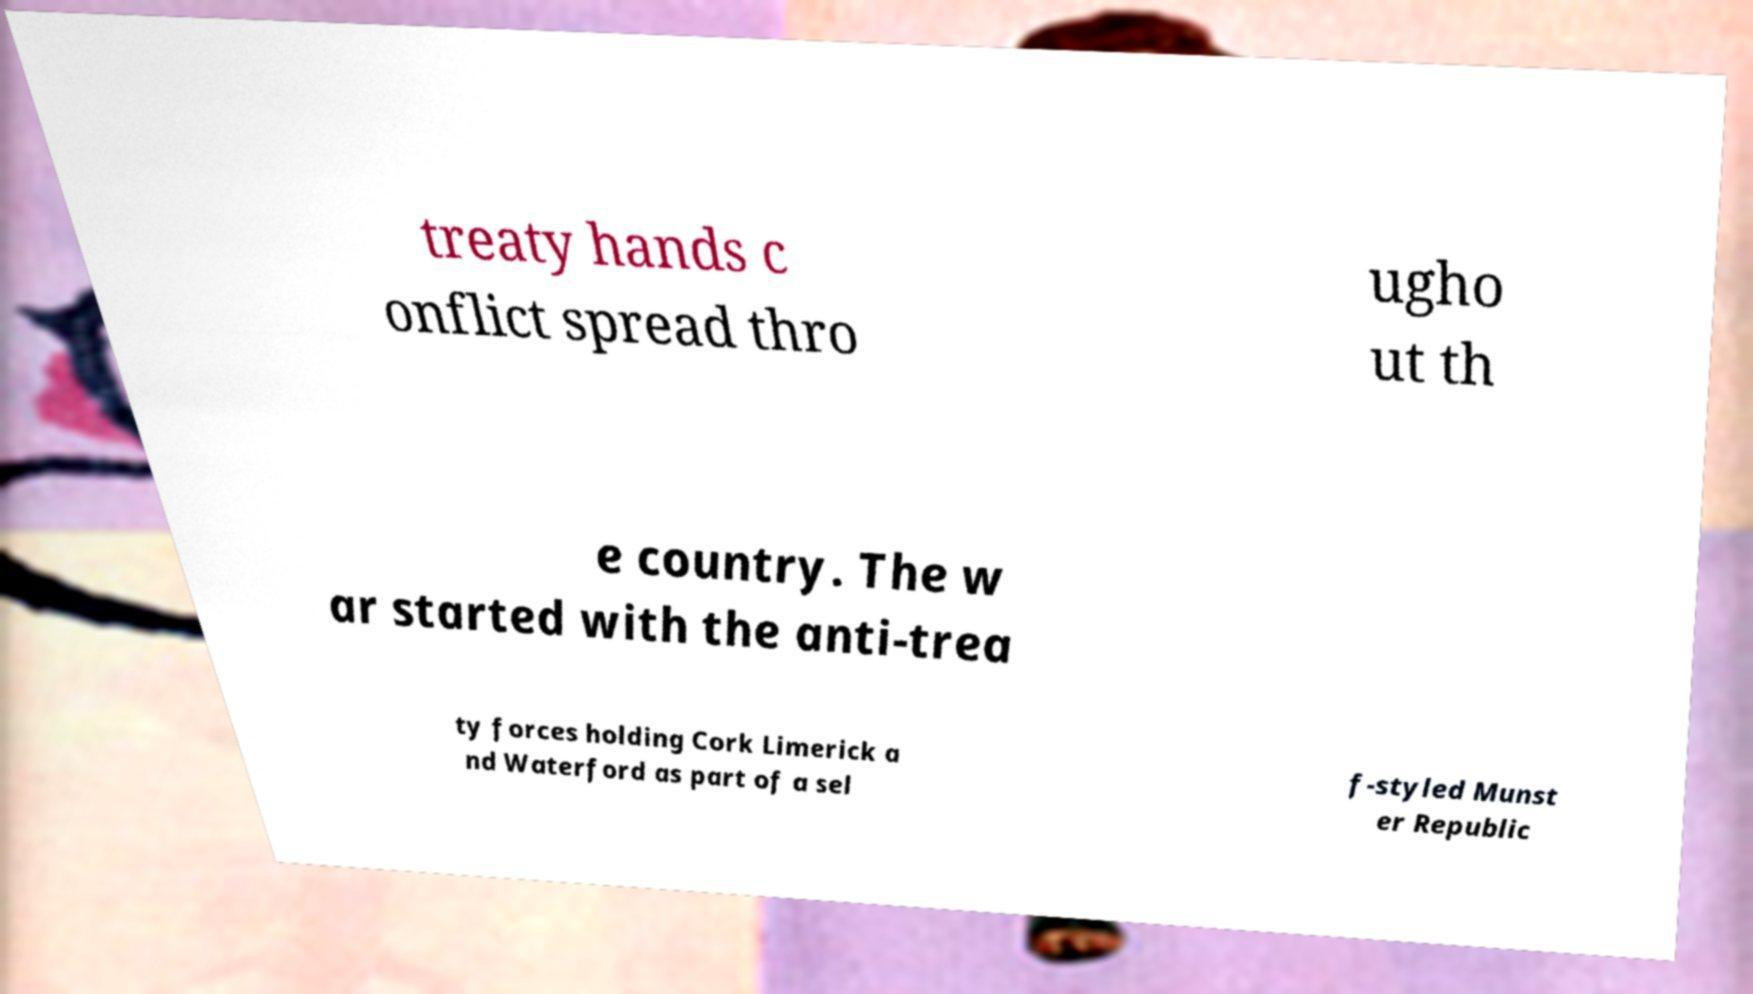Can you accurately transcribe the text from the provided image for me? treaty hands c onflict spread thro ugho ut th e country. The w ar started with the anti-trea ty forces holding Cork Limerick a nd Waterford as part of a sel f-styled Munst er Republic 